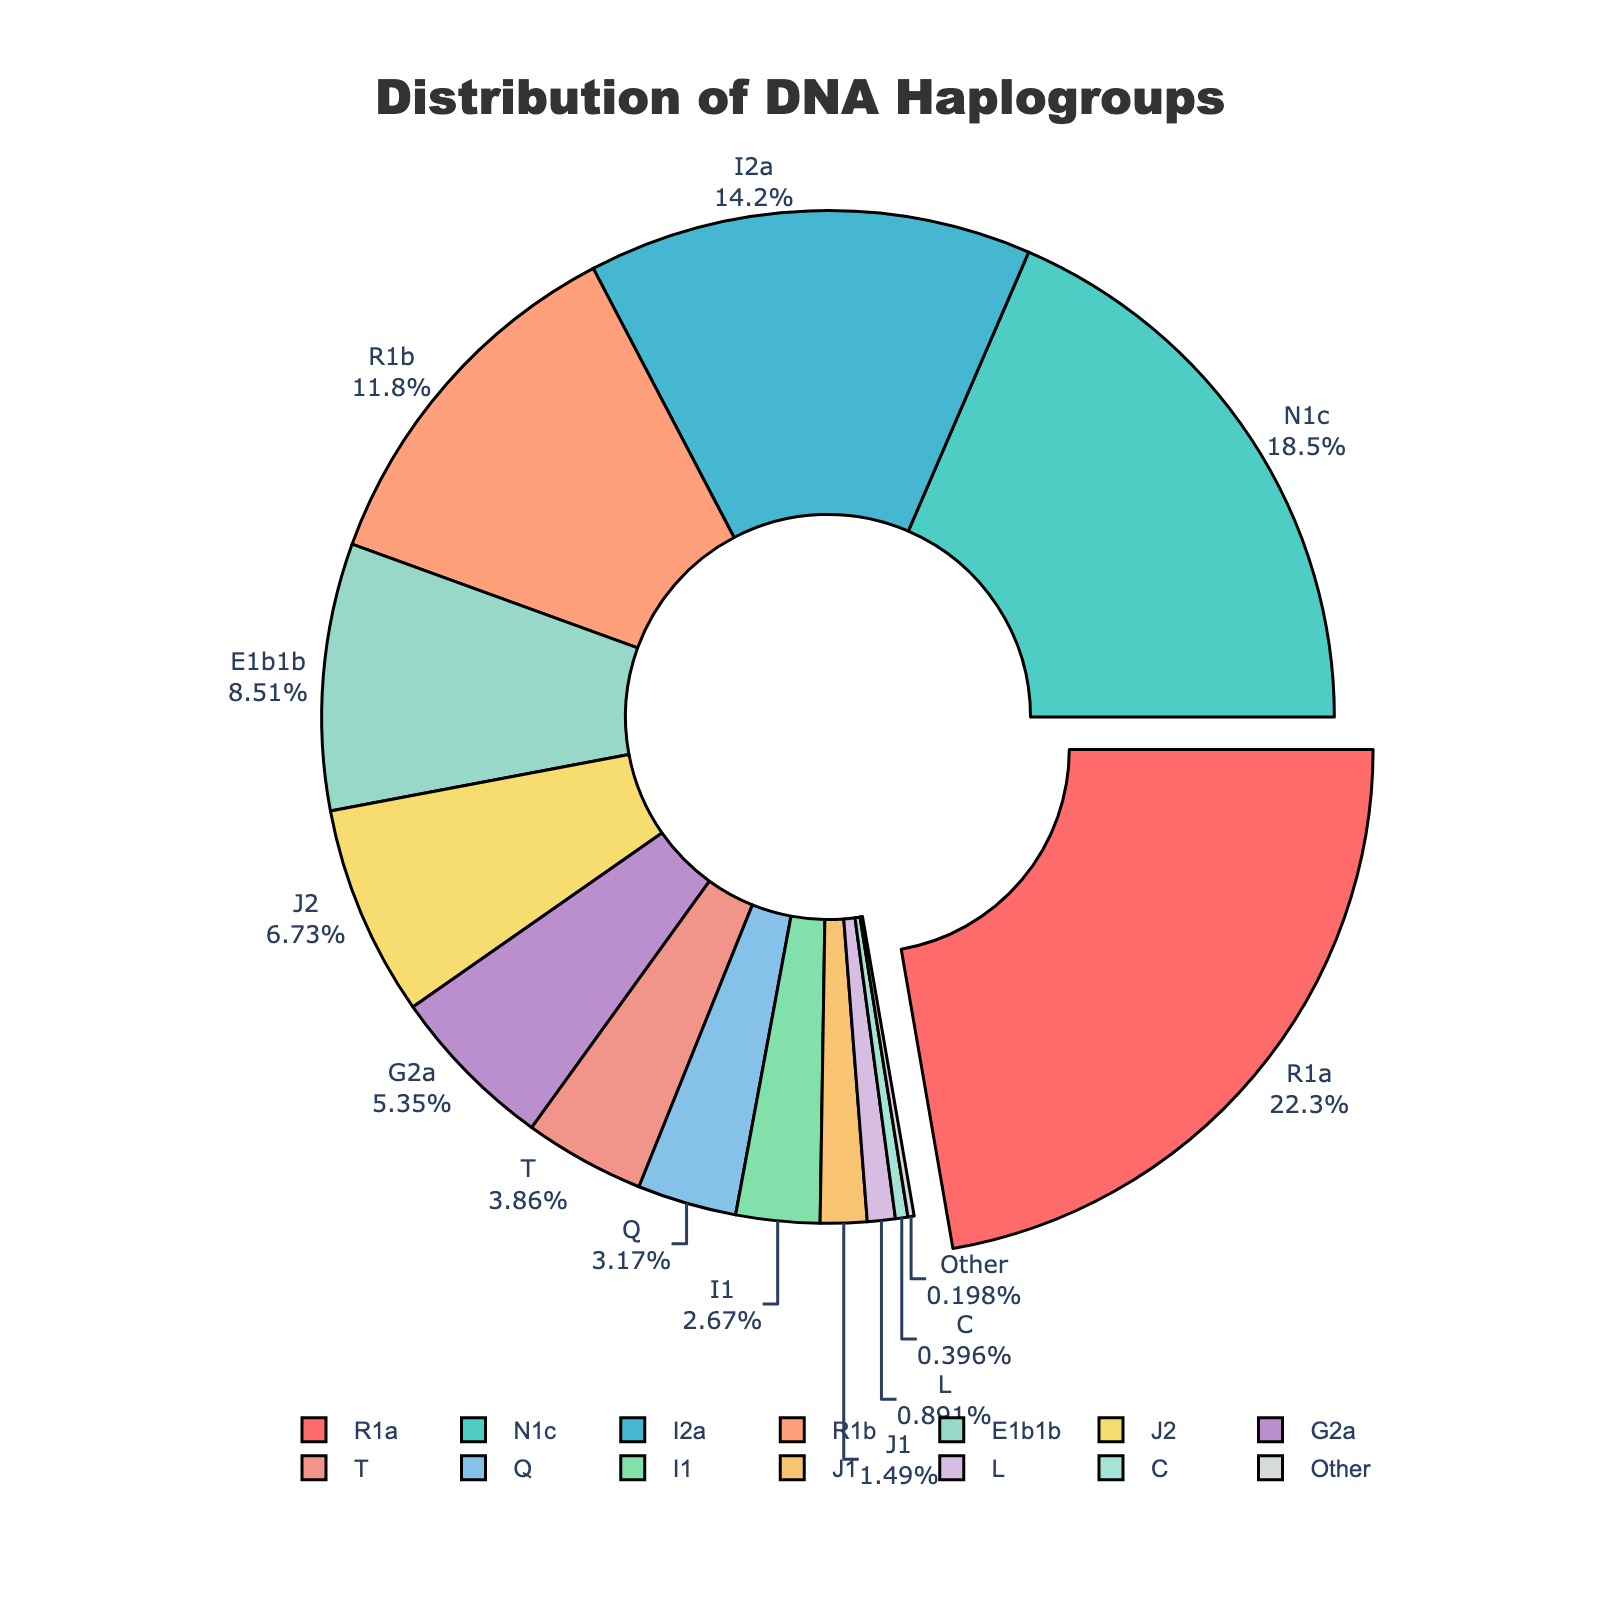What's the most common haplogroup in this distribution? To determine the most common haplogroup, identify the segment with the largest proportion in the pie chart. In this case, it is clear that haplogroup R1a has the highest percentage at 22.5%.
Answer: R1a Which haplogroup is the least common, and what is its percentage? To find the least common haplogroup, look for the segment with the smallest proportion. According to the chart, haplogroup "Other" has the smallest proportion at 0.2%.
Answer: Other, 0.2% What is the combined percentage of haplogroups R1a and N1c? To find the combined percentage, add the percentages of R1a and N1c. R1a has 22.5% and N1c has 18.7%. So, 22.5% + 18.7% = 41.2%.
Answer: 41.2% Which haplogroups make up more than 10% of the distribution? To identify haplogroups with more than 10%, examine each segment. Haplogroups R1a (22.5%), N1c (18.7%), I2a (14.3%), and R1b (11.9%) are above 10%.
Answer: R1a, N1c, I2a, R1b How does the percentage of haplogroup J2 compare to that of haplogroup G2a? Compare the segments labeled J2 and G2a. J2 has a percentage of 6.8%, whereas G2a has 5.4%. Since 6.8% is higher than 5.4%, J2 is more prevalent.
Answer: J2 > G2a Which haplogroup has a percentage closest to the median percentage of all haplogroups? First, sort the percentages of all haplogroups, then find the median value. The sorted percentages are: [0.2, 0.4, 0.9, 1.5, 2.7, 3.2, 3.9, 5.4, 6.8, 8.6, 11.9, 14.3, 18.7, 22.5]. The median value (middle of the sorted list of 14) is the average of the 7th and 8th values: (3.9 + 5.4) / 2 = 4.65. The closest percentage to 4.65 is 5.4%, corresponding to haplogroup G2a.
Answer: G2a What is the total percentage of haplogroups T, Q, and I1? Add the percentages of haplogroups T, Q, and I1. T has 3.9%, Q has 3.2%, and I1 has 2.7%. So, 3.9% + 3.2% + 2.7% = 9.8%.
Answer: 9.8% If the percentages of haplogroups sorted from highest to lowest were ordinal, what position would haplogroup E1b1b hold? Arrange the haplogroups in descending order based on their percentages. The order would be R1a, N1c, I2a, R1b, E1b1b, J2, G2a, T, Q, I1, J1, L, C, Other. E1b1b comes 5th in this order.
Answer: 5th 